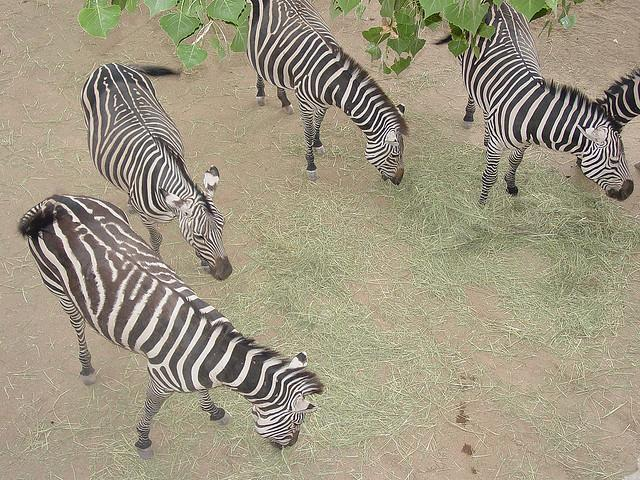How many zebras are standing on the hay below the tree? Please explain your reasoning. four. There are four zebras by the tree. 